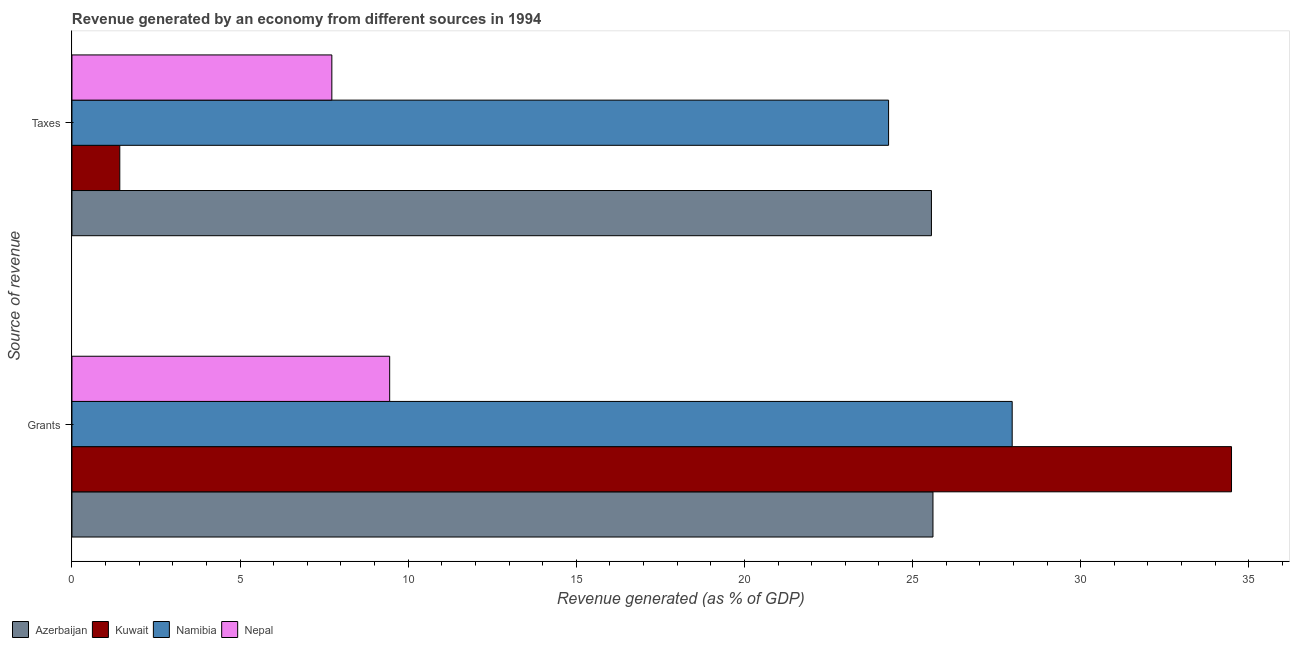How many different coloured bars are there?
Make the answer very short. 4. What is the label of the 1st group of bars from the top?
Give a very brief answer. Taxes. What is the revenue generated by grants in Nepal?
Give a very brief answer. 9.45. Across all countries, what is the maximum revenue generated by taxes?
Provide a succinct answer. 25.56. Across all countries, what is the minimum revenue generated by grants?
Offer a terse response. 9.45. In which country was the revenue generated by grants maximum?
Offer a terse response. Kuwait. In which country was the revenue generated by grants minimum?
Keep it short and to the point. Nepal. What is the total revenue generated by grants in the graph?
Your response must be concise. 97.5. What is the difference between the revenue generated by taxes in Nepal and that in Kuwait?
Your answer should be compact. 6.31. What is the difference between the revenue generated by grants in Kuwait and the revenue generated by taxes in Nepal?
Offer a terse response. 26.76. What is the average revenue generated by taxes per country?
Your response must be concise. 14.75. What is the difference between the revenue generated by grants and revenue generated by taxes in Nepal?
Your answer should be compact. 1.72. In how many countries, is the revenue generated by taxes greater than 27 %?
Your answer should be very brief. 0. What is the ratio of the revenue generated by grants in Namibia to that in Nepal?
Make the answer very short. 2.96. Is the revenue generated by taxes in Azerbaijan less than that in Namibia?
Your answer should be compact. No. What does the 1st bar from the top in Taxes represents?
Ensure brevity in your answer.  Nepal. What does the 1st bar from the bottom in Grants represents?
Provide a succinct answer. Azerbaijan. How many countries are there in the graph?
Give a very brief answer. 4. What is the difference between two consecutive major ticks on the X-axis?
Provide a short and direct response. 5. Does the graph contain any zero values?
Your answer should be compact. No. Where does the legend appear in the graph?
Offer a terse response. Bottom left. How many legend labels are there?
Make the answer very short. 4. What is the title of the graph?
Offer a very short reply. Revenue generated by an economy from different sources in 1994. What is the label or title of the X-axis?
Ensure brevity in your answer.  Revenue generated (as % of GDP). What is the label or title of the Y-axis?
Offer a terse response. Source of revenue. What is the Revenue generated (as % of GDP) in Azerbaijan in Grants?
Provide a succinct answer. 25.61. What is the Revenue generated (as % of GDP) of Kuwait in Grants?
Offer a very short reply. 34.49. What is the Revenue generated (as % of GDP) of Namibia in Grants?
Offer a very short reply. 27.96. What is the Revenue generated (as % of GDP) in Nepal in Grants?
Offer a very short reply. 9.45. What is the Revenue generated (as % of GDP) of Azerbaijan in Taxes?
Give a very brief answer. 25.56. What is the Revenue generated (as % of GDP) in Kuwait in Taxes?
Your response must be concise. 1.42. What is the Revenue generated (as % of GDP) of Namibia in Taxes?
Provide a succinct answer. 24.29. What is the Revenue generated (as % of GDP) of Nepal in Taxes?
Your answer should be very brief. 7.73. Across all Source of revenue, what is the maximum Revenue generated (as % of GDP) of Azerbaijan?
Provide a short and direct response. 25.61. Across all Source of revenue, what is the maximum Revenue generated (as % of GDP) in Kuwait?
Provide a short and direct response. 34.49. Across all Source of revenue, what is the maximum Revenue generated (as % of GDP) of Namibia?
Your response must be concise. 27.96. Across all Source of revenue, what is the maximum Revenue generated (as % of GDP) in Nepal?
Make the answer very short. 9.45. Across all Source of revenue, what is the minimum Revenue generated (as % of GDP) of Azerbaijan?
Keep it short and to the point. 25.56. Across all Source of revenue, what is the minimum Revenue generated (as % of GDP) of Kuwait?
Offer a very short reply. 1.42. Across all Source of revenue, what is the minimum Revenue generated (as % of GDP) in Namibia?
Your answer should be compact. 24.29. Across all Source of revenue, what is the minimum Revenue generated (as % of GDP) of Nepal?
Keep it short and to the point. 7.73. What is the total Revenue generated (as % of GDP) in Azerbaijan in the graph?
Provide a short and direct response. 51.17. What is the total Revenue generated (as % of GDP) of Kuwait in the graph?
Offer a terse response. 35.91. What is the total Revenue generated (as % of GDP) in Namibia in the graph?
Offer a terse response. 52.25. What is the total Revenue generated (as % of GDP) of Nepal in the graph?
Make the answer very short. 17.18. What is the difference between the Revenue generated (as % of GDP) of Azerbaijan in Grants and that in Taxes?
Offer a very short reply. 0.05. What is the difference between the Revenue generated (as % of GDP) of Kuwait in Grants and that in Taxes?
Ensure brevity in your answer.  33.06. What is the difference between the Revenue generated (as % of GDP) of Namibia in Grants and that in Taxes?
Offer a terse response. 3.68. What is the difference between the Revenue generated (as % of GDP) in Nepal in Grants and that in Taxes?
Your answer should be compact. 1.72. What is the difference between the Revenue generated (as % of GDP) in Azerbaijan in Grants and the Revenue generated (as % of GDP) in Kuwait in Taxes?
Your response must be concise. 24.18. What is the difference between the Revenue generated (as % of GDP) in Azerbaijan in Grants and the Revenue generated (as % of GDP) in Namibia in Taxes?
Make the answer very short. 1.32. What is the difference between the Revenue generated (as % of GDP) in Azerbaijan in Grants and the Revenue generated (as % of GDP) in Nepal in Taxes?
Make the answer very short. 17.88. What is the difference between the Revenue generated (as % of GDP) of Kuwait in Grants and the Revenue generated (as % of GDP) of Namibia in Taxes?
Give a very brief answer. 10.2. What is the difference between the Revenue generated (as % of GDP) of Kuwait in Grants and the Revenue generated (as % of GDP) of Nepal in Taxes?
Your answer should be compact. 26.76. What is the difference between the Revenue generated (as % of GDP) of Namibia in Grants and the Revenue generated (as % of GDP) of Nepal in Taxes?
Make the answer very short. 20.23. What is the average Revenue generated (as % of GDP) in Azerbaijan per Source of revenue?
Your response must be concise. 25.58. What is the average Revenue generated (as % of GDP) in Kuwait per Source of revenue?
Make the answer very short. 17.95. What is the average Revenue generated (as % of GDP) in Namibia per Source of revenue?
Your response must be concise. 26.12. What is the average Revenue generated (as % of GDP) in Nepal per Source of revenue?
Keep it short and to the point. 8.59. What is the difference between the Revenue generated (as % of GDP) in Azerbaijan and Revenue generated (as % of GDP) in Kuwait in Grants?
Your answer should be very brief. -8.88. What is the difference between the Revenue generated (as % of GDP) in Azerbaijan and Revenue generated (as % of GDP) in Namibia in Grants?
Your answer should be very brief. -2.36. What is the difference between the Revenue generated (as % of GDP) of Azerbaijan and Revenue generated (as % of GDP) of Nepal in Grants?
Provide a succinct answer. 16.16. What is the difference between the Revenue generated (as % of GDP) in Kuwait and Revenue generated (as % of GDP) in Namibia in Grants?
Make the answer very short. 6.52. What is the difference between the Revenue generated (as % of GDP) in Kuwait and Revenue generated (as % of GDP) in Nepal in Grants?
Give a very brief answer. 25.04. What is the difference between the Revenue generated (as % of GDP) in Namibia and Revenue generated (as % of GDP) in Nepal in Grants?
Your answer should be very brief. 18.51. What is the difference between the Revenue generated (as % of GDP) in Azerbaijan and Revenue generated (as % of GDP) in Kuwait in Taxes?
Offer a very short reply. 24.14. What is the difference between the Revenue generated (as % of GDP) in Azerbaijan and Revenue generated (as % of GDP) in Namibia in Taxes?
Give a very brief answer. 1.27. What is the difference between the Revenue generated (as % of GDP) of Azerbaijan and Revenue generated (as % of GDP) of Nepal in Taxes?
Provide a short and direct response. 17.83. What is the difference between the Revenue generated (as % of GDP) in Kuwait and Revenue generated (as % of GDP) in Namibia in Taxes?
Keep it short and to the point. -22.86. What is the difference between the Revenue generated (as % of GDP) in Kuwait and Revenue generated (as % of GDP) in Nepal in Taxes?
Your response must be concise. -6.31. What is the difference between the Revenue generated (as % of GDP) in Namibia and Revenue generated (as % of GDP) in Nepal in Taxes?
Offer a terse response. 16.56. What is the ratio of the Revenue generated (as % of GDP) in Azerbaijan in Grants to that in Taxes?
Offer a very short reply. 1. What is the ratio of the Revenue generated (as % of GDP) in Kuwait in Grants to that in Taxes?
Offer a terse response. 24.24. What is the ratio of the Revenue generated (as % of GDP) in Namibia in Grants to that in Taxes?
Make the answer very short. 1.15. What is the ratio of the Revenue generated (as % of GDP) in Nepal in Grants to that in Taxes?
Give a very brief answer. 1.22. What is the difference between the highest and the second highest Revenue generated (as % of GDP) of Azerbaijan?
Provide a succinct answer. 0.05. What is the difference between the highest and the second highest Revenue generated (as % of GDP) in Kuwait?
Your answer should be very brief. 33.06. What is the difference between the highest and the second highest Revenue generated (as % of GDP) of Namibia?
Your answer should be compact. 3.68. What is the difference between the highest and the second highest Revenue generated (as % of GDP) in Nepal?
Provide a succinct answer. 1.72. What is the difference between the highest and the lowest Revenue generated (as % of GDP) in Azerbaijan?
Make the answer very short. 0.05. What is the difference between the highest and the lowest Revenue generated (as % of GDP) in Kuwait?
Make the answer very short. 33.06. What is the difference between the highest and the lowest Revenue generated (as % of GDP) in Namibia?
Offer a very short reply. 3.68. What is the difference between the highest and the lowest Revenue generated (as % of GDP) of Nepal?
Give a very brief answer. 1.72. 